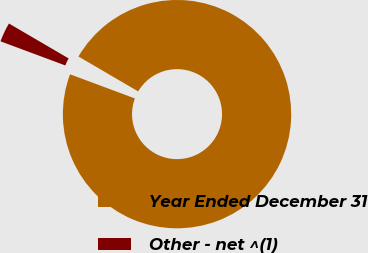Convert chart to OTSL. <chart><loc_0><loc_0><loc_500><loc_500><pie_chart><fcel>Year Ended December 31<fcel>Other - net ^(1)<nl><fcel>97.25%<fcel>2.75%<nl></chart> 